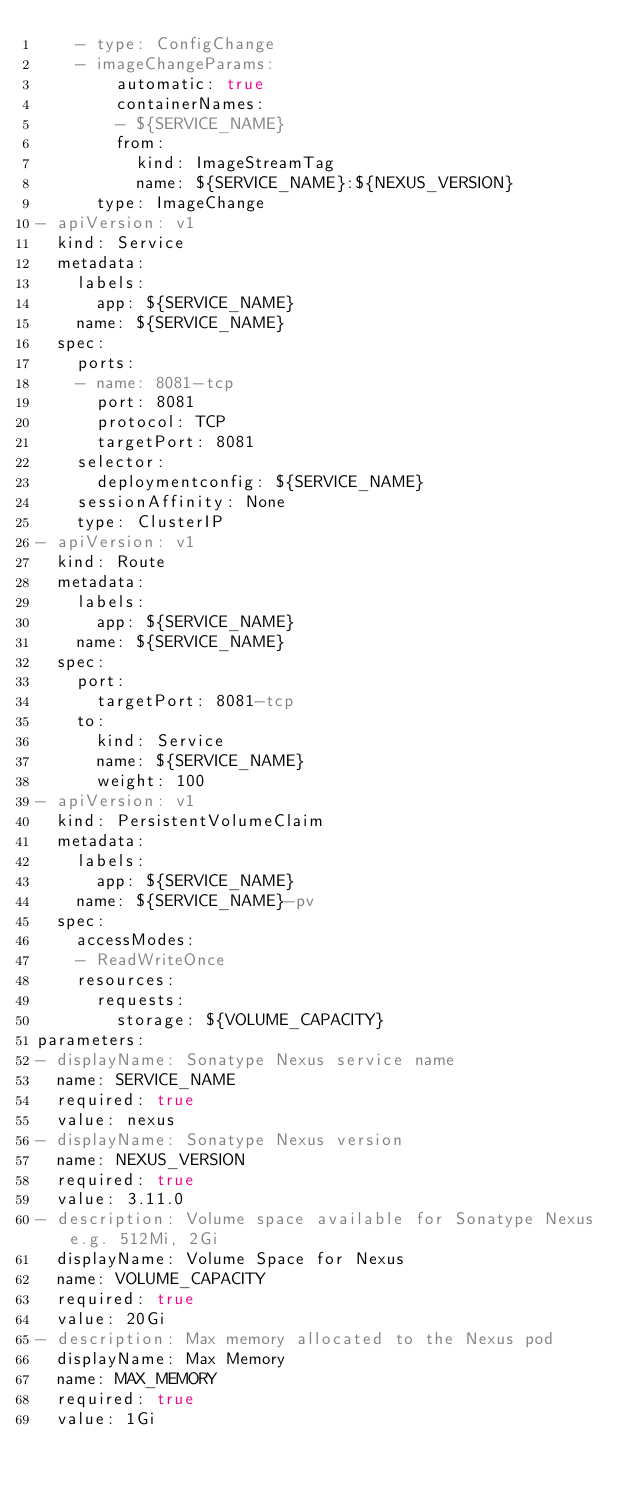Convert code to text. <code><loc_0><loc_0><loc_500><loc_500><_YAML_>    - type: ConfigChange
    - imageChangeParams:
        automatic: true
        containerNames:
        - ${SERVICE_NAME}
        from:
          kind: ImageStreamTag
          name: ${SERVICE_NAME}:${NEXUS_VERSION}
      type: ImageChange
- apiVersion: v1
  kind: Service
  metadata:
    labels:
      app: ${SERVICE_NAME}
    name: ${SERVICE_NAME}
  spec:
    ports:
    - name: 8081-tcp
      port: 8081
      protocol: TCP
      targetPort: 8081
    selector:
      deploymentconfig: ${SERVICE_NAME}
    sessionAffinity: None
    type: ClusterIP
- apiVersion: v1
  kind: Route
  metadata:
    labels:
      app: ${SERVICE_NAME}
    name: ${SERVICE_NAME}
  spec:
    port:
      targetPort: 8081-tcp
    to:
      kind: Service
      name: ${SERVICE_NAME}
      weight: 100
- apiVersion: v1
  kind: PersistentVolumeClaim
  metadata:
    labels:
      app: ${SERVICE_NAME}
    name: ${SERVICE_NAME}-pv
  spec:
    accessModes:
    - ReadWriteOnce
    resources:
      requests:
        storage: ${VOLUME_CAPACITY}
parameters:
- displayName: Sonatype Nexus service name
  name: SERVICE_NAME
  required: true
  value: nexus
- displayName: Sonatype Nexus version
  name: NEXUS_VERSION
  required: true
  value: 3.11.0
- description: Volume space available for Sonatype Nexus e.g. 512Mi, 2Gi
  displayName: Volume Space for Nexus
  name: VOLUME_CAPACITY
  required: true
  value: 20Gi
- description: Max memory allocated to the Nexus pod
  displayName: Max Memory
  name: MAX_MEMORY
  required: true
  value: 1Gi
</code> 